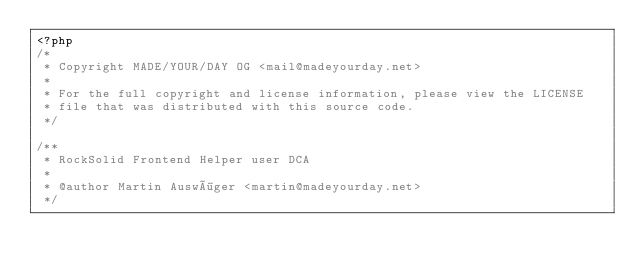<code> <loc_0><loc_0><loc_500><loc_500><_PHP_><?php
/*
 * Copyright MADE/YOUR/DAY OG <mail@madeyourday.net>
 *
 * For the full copyright and license information, please view the LICENSE
 * file that was distributed with this source code.
 */

/**
 * RockSolid Frontend Helper user DCA
 *
 * @author Martin Auswöger <martin@madeyourday.net>
 */
</code> 